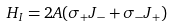<formula> <loc_0><loc_0><loc_500><loc_500>H _ { I } = 2 A ( \sigma _ { + } J _ { - } + \sigma _ { - } J _ { + } )</formula> 